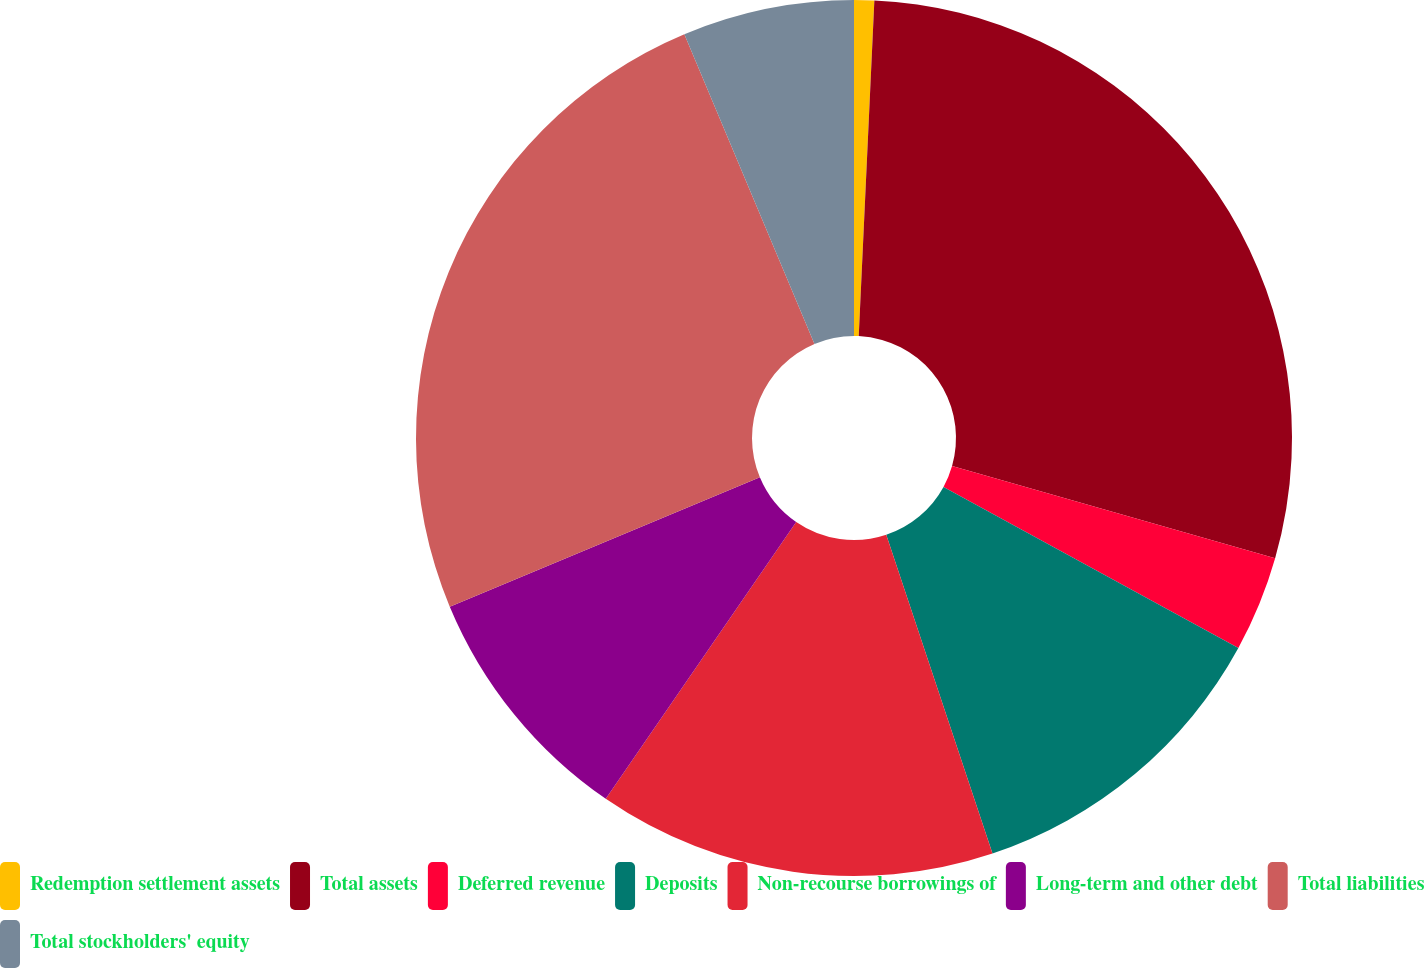Convert chart to OTSL. <chart><loc_0><loc_0><loc_500><loc_500><pie_chart><fcel>Redemption settlement assets<fcel>Total assets<fcel>Deferred revenue<fcel>Deposits<fcel>Non-recourse borrowings of<fcel>Long-term and other debt<fcel>Total liabilities<fcel>Total stockholders' equity<nl><fcel>0.74%<fcel>28.69%<fcel>3.53%<fcel>11.92%<fcel>14.71%<fcel>9.12%<fcel>24.96%<fcel>6.33%<nl></chart> 